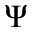Convert formula to latex. <formula><loc_0><loc_0><loc_500><loc_500>\Psi</formula> 